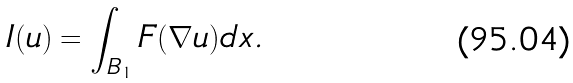<formula> <loc_0><loc_0><loc_500><loc_500>I ( u ) = \int _ { B _ { 1 } } F ( \nabla u ) d x .</formula> 